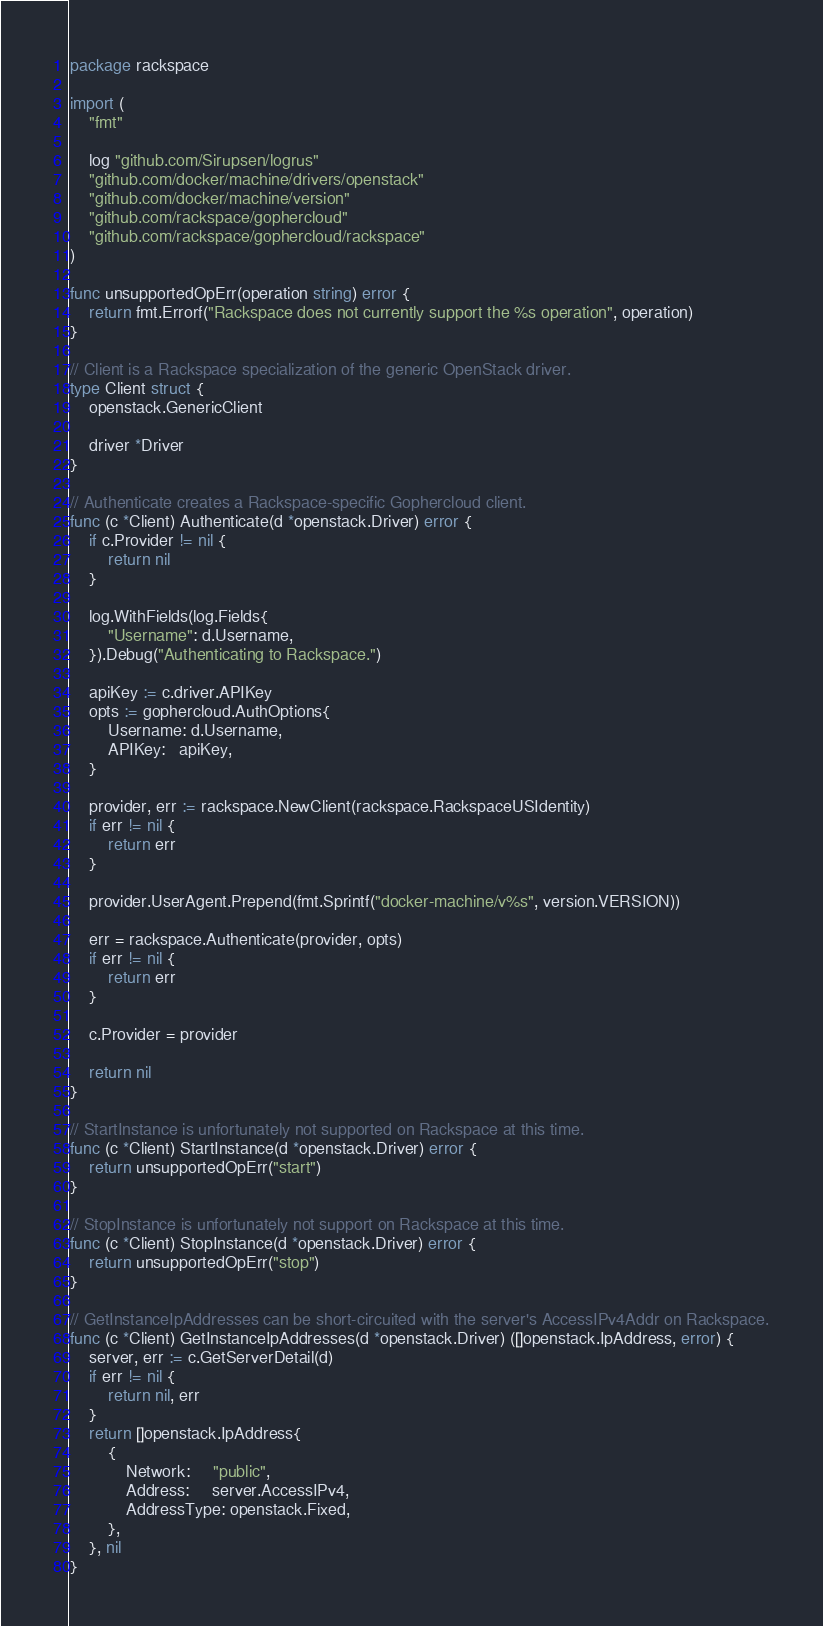<code> <loc_0><loc_0><loc_500><loc_500><_Go_>package rackspace

import (
	"fmt"

	log "github.com/Sirupsen/logrus"
	"github.com/docker/machine/drivers/openstack"
	"github.com/docker/machine/version"
	"github.com/rackspace/gophercloud"
	"github.com/rackspace/gophercloud/rackspace"
)

func unsupportedOpErr(operation string) error {
	return fmt.Errorf("Rackspace does not currently support the %s operation", operation)
}

// Client is a Rackspace specialization of the generic OpenStack driver.
type Client struct {
	openstack.GenericClient

	driver *Driver
}

// Authenticate creates a Rackspace-specific Gophercloud client.
func (c *Client) Authenticate(d *openstack.Driver) error {
	if c.Provider != nil {
		return nil
	}

	log.WithFields(log.Fields{
		"Username": d.Username,
	}).Debug("Authenticating to Rackspace.")

	apiKey := c.driver.APIKey
	opts := gophercloud.AuthOptions{
		Username: d.Username,
		APIKey:   apiKey,
	}

	provider, err := rackspace.NewClient(rackspace.RackspaceUSIdentity)
	if err != nil {
		return err
	}

	provider.UserAgent.Prepend(fmt.Sprintf("docker-machine/v%s", version.VERSION))

	err = rackspace.Authenticate(provider, opts)
	if err != nil {
		return err
	}

	c.Provider = provider

	return nil
}

// StartInstance is unfortunately not supported on Rackspace at this time.
func (c *Client) StartInstance(d *openstack.Driver) error {
	return unsupportedOpErr("start")
}

// StopInstance is unfortunately not support on Rackspace at this time.
func (c *Client) StopInstance(d *openstack.Driver) error {
	return unsupportedOpErr("stop")
}

// GetInstanceIpAddresses can be short-circuited with the server's AccessIPv4Addr on Rackspace.
func (c *Client) GetInstanceIpAddresses(d *openstack.Driver) ([]openstack.IpAddress, error) {
	server, err := c.GetServerDetail(d)
	if err != nil {
		return nil, err
	}
	return []openstack.IpAddress{
		{
			Network:     "public",
			Address:     server.AccessIPv4,
			AddressType: openstack.Fixed,
		},
	}, nil
}
</code> 